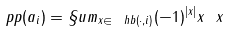Convert formula to latex. <formula><loc_0><loc_0><loc_500><loc_500>\ p p ( a _ { i } ) = \S u m _ { x \in \ h b ( \cdot , i ) } ( - 1 ) ^ { | x | } x \ x</formula> 